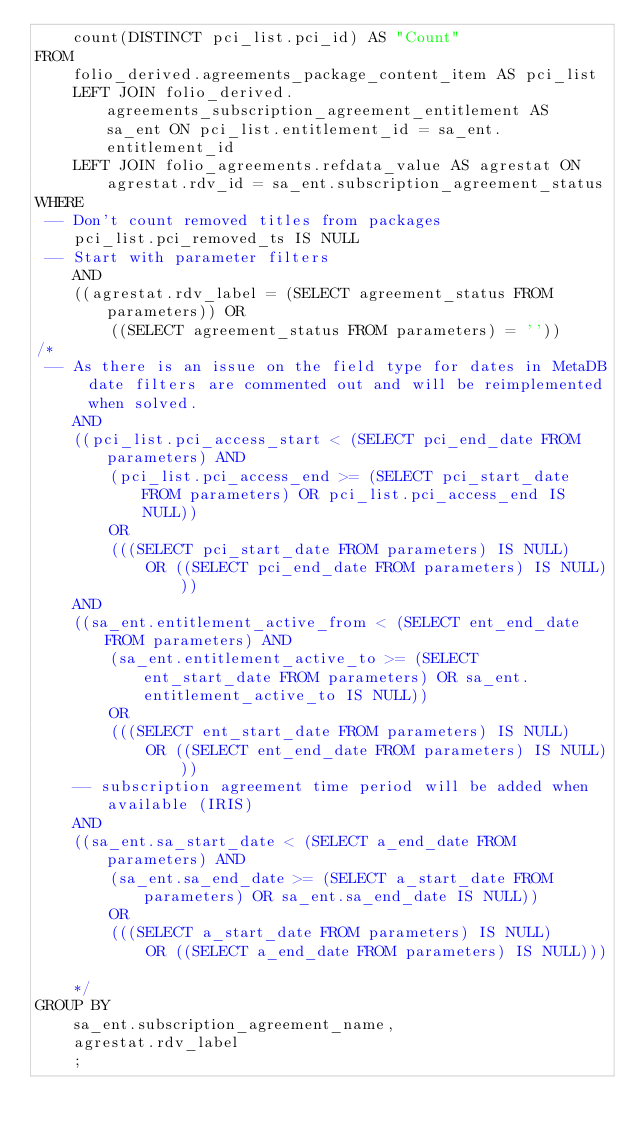Convert code to text. <code><loc_0><loc_0><loc_500><loc_500><_SQL_>    count(DISTINCT pci_list.pci_id) AS "Count"
FROM
    folio_derived.agreements_package_content_item AS pci_list
    LEFT JOIN folio_derived.agreements_subscription_agreement_entitlement AS sa_ent ON pci_list.entitlement_id = sa_ent.entitlement_id
    LEFT JOIN folio_agreements.refdata_value AS agrestat ON agrestat.rdv_id = sa_ent.subscription_agreement_status
WHERE
 -- Don't count removed titles from packages
    pci_list.pci_removed_ts IS NULL
 -- Start with parameter filters
    AND
	((agrestat.rdv_label = (SELECT agreement_status FROM parameters)) OR
		((SELECT agreement_status FROM parameters) = ''))
/*	
 -- As there is an issue on the field type for dates in MetaDB date filters are commented out and will be reimplemented when solved.
	AND
    ((pci_list.pci_access_start < (SELECT pci_end_date FROM parameters) AND
	    (pci_list.pci_access_end >= (SELECT pci_start_date FROM parameters) OR pci_list.pci_access_end IS NULL))
	    OR
		(((SELECT pci_start_date FROM parameters) IS NULL)
			OR ((SELECT pci_end_date FROM parameters) IS NULL)))
	AND
    ((sa_ent.entitlement_active_from < (SELECT ent_end_date FROM parameters) AND
	    (sa_ent.entitlement_active_to >= (SELECT ent_start_date FROM parameters) OR sa_ent.entitlement_active_to IS NULL))
	    OR
		(((SELECT ent_start_date FROM parameters) IS NULL)
			OR ((SELECT ent_end_date FROM parameters) IS NULL)))
	-- subscription agreement time period will be added when available (IRIS)
	AND 			
    ((sa_ent.sa_start_date < (SELECT a_end_date FROM parameters) AND
	    (sa_ent.sa_end_date >= (SELECT a_start_date FROM parameters) OR sa_ent.sa_end_date IS NULL))
	    OR 
		(((SELECT a_start_date FROM parameters) IS NULL) 
			OR ((SELECT a_end_date FROM parameters) IS NULL)))	
	*/
GROUP BY
    sa_ent.subscription_agreement_name,
    agrestat.rdv_label
    ;


</code> 